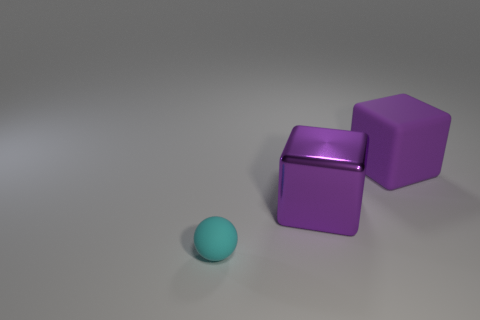Is there anything else that is the same color as the small matte object?
Give a very brief answer. No. Are there fewer big purple shiny cubes than large brown shiny objects?
Your answer should be very brief. No. What shape is the big shiny thing that is the same color as the rubber block?
Ensure brevity in your answer.  Cube. There is a tiny cyan rubber ball; how many large purple metallic blocks are on the right side of it?
Your answer should be very brief. 1. Is the shape of the small cyan thing the same as the big matte object?
Your answer should be very brief. No. How many things are behind the small cyan matte ball and left of the purple matte block?
Your answer should be very brief. 1. How many things are either large red rubber blocks or matte objects to the right of the cyan object?
Make the answer very short. 1. Is the number of large yellow cylinders greater than the number of big purple objects?
Your response must be concise. No. There is a purple thing that is in front of the large matte cube; what is its shape?
Offer a very short reply. Cube. What number of big purple metallic things are the same shape as the small thing?
Provide a succinct answer. 0. 